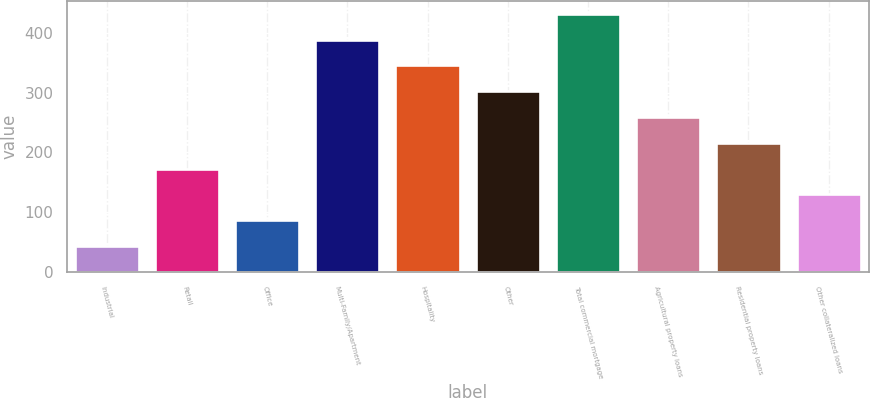<chart> <loc_0><loc_0><loc_500><loc_500><bar_chart><fcel>Industrial<fcel>Retail<fcel>Office<fcel>Multi-Family/Apartment<fcel>Hospitality<fcel>Other<fcel>Total commercial mortgage<fcel>Agricultural property loans<fcel>Residential property loans<fcel>Other collateralized loans<nl><fcel>43.58<fcel>173.06<fcel>86.74<fcel>388.86<fcel>345.7<fcel>302.54<fcel>432.02<fcel>259.38<fcel>216.22<fcel>129.9<nl></chart> 